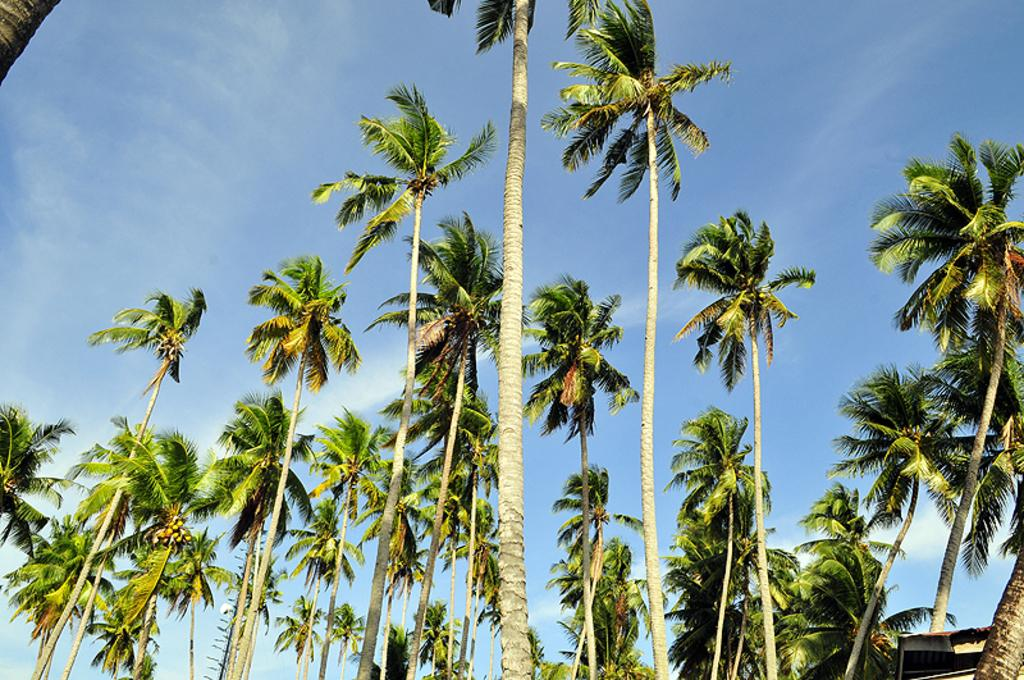What type of trees are present in the image? There are coconut trees in the image. What can be seen in the background of the image? The sky is visible in the background of the image. What is the condition of the sky in the image? There are clouds in the sky in the image. What color is the sister's wine in the image? There is no sister or wine present in the image. 